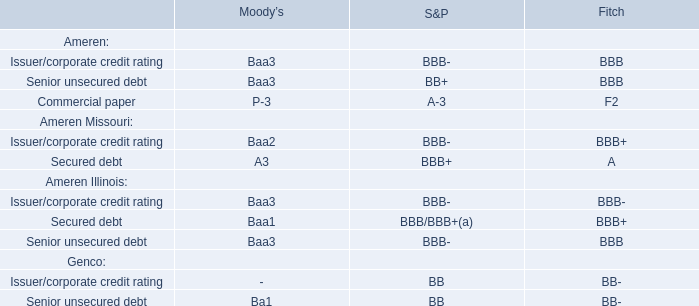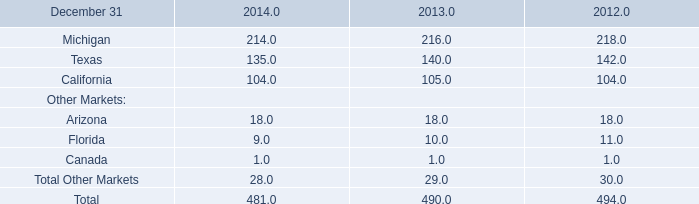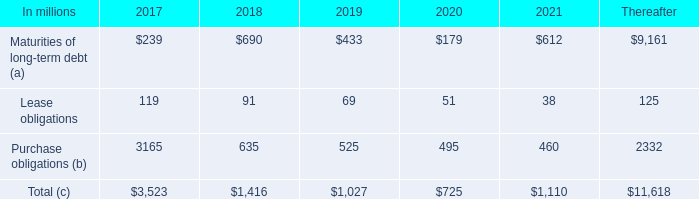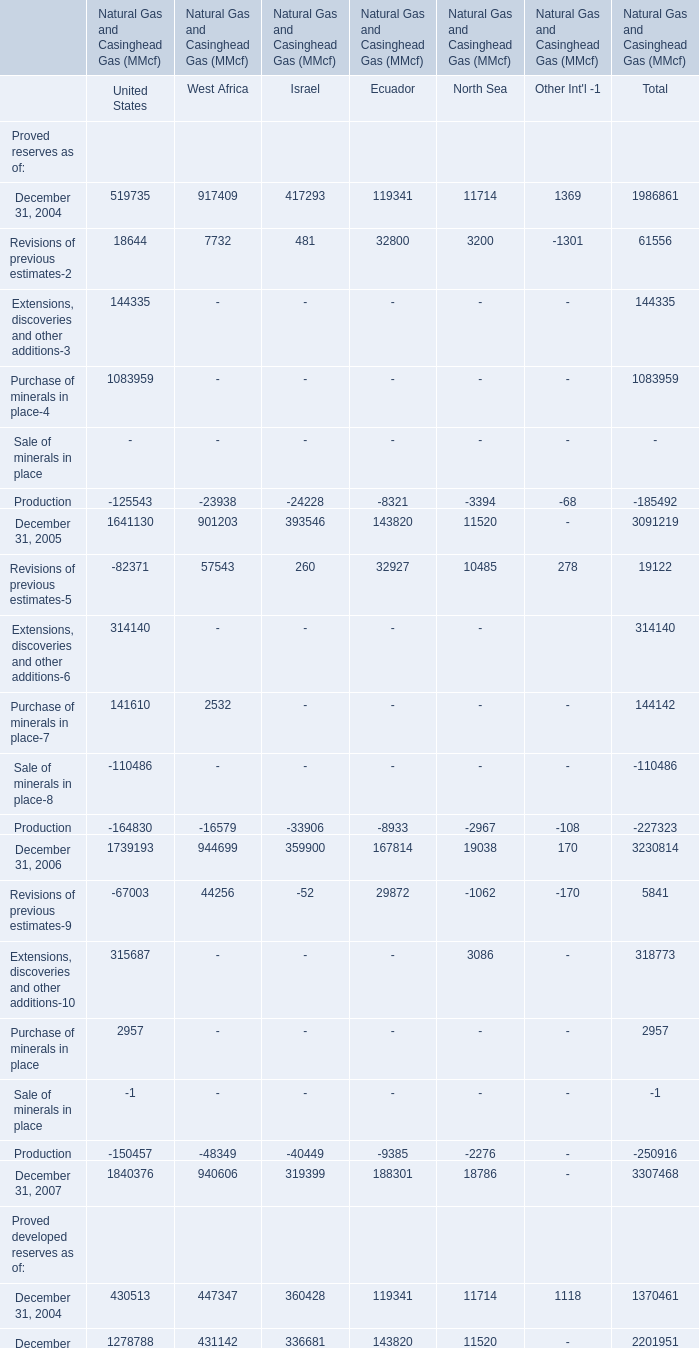Which reserves occupies the greatest proportion in total amount (in 2004)? 
Answer: 447347.0. 